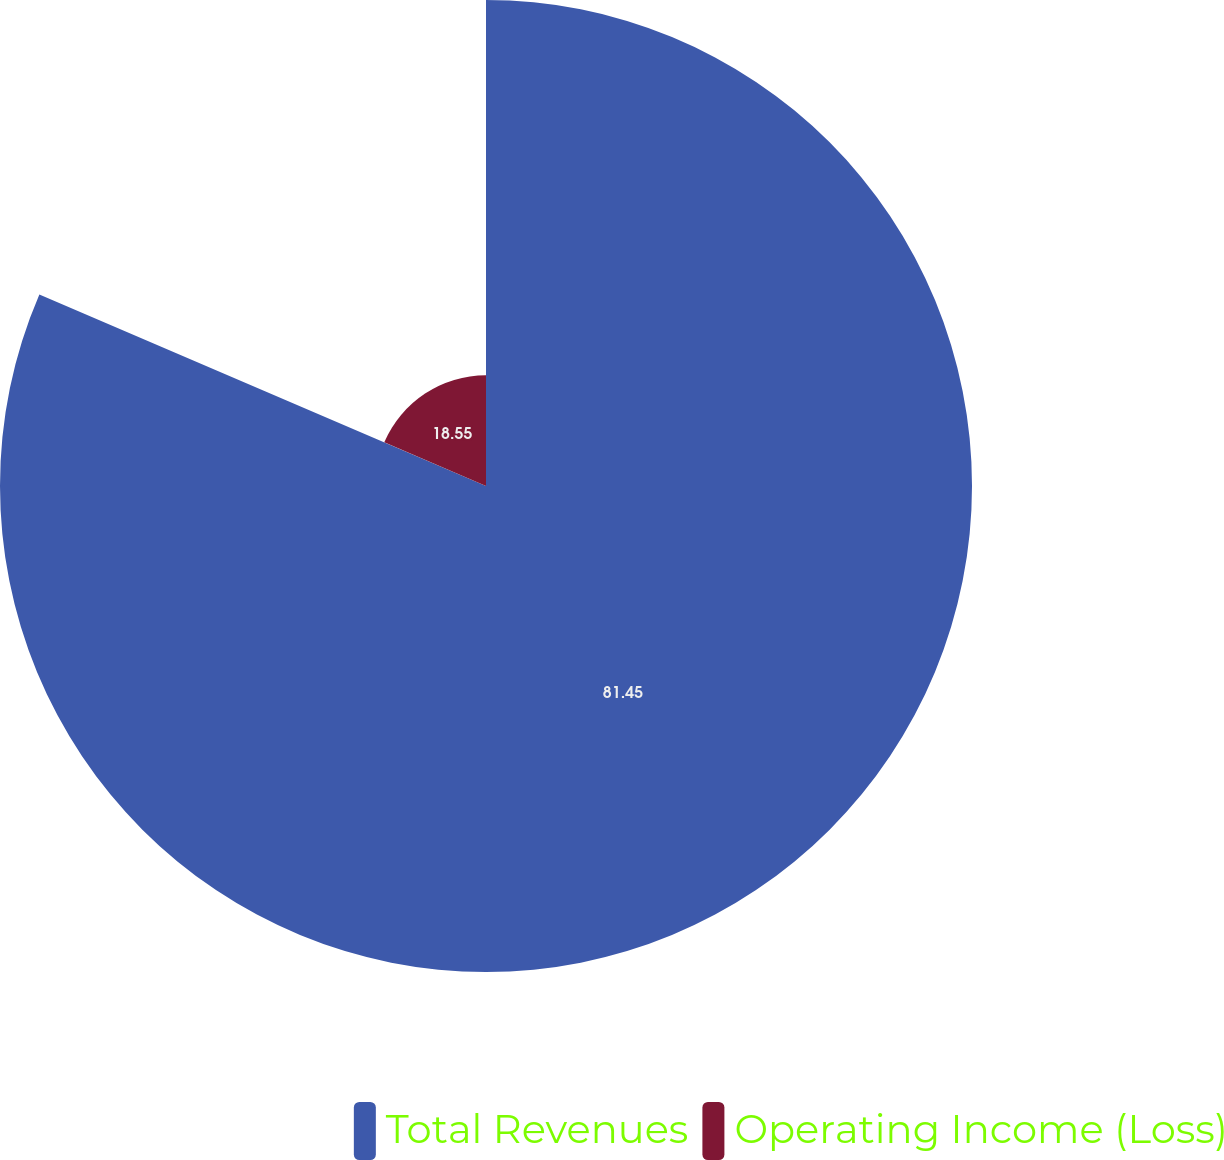Convert chart to OTSL. <chart><loc_0><loc_0><loc_500><loc_500><pie_chart><fcel>Total Revenues<fcel>Operating Income (Loss)<nl><fcel>81.45%<fcel>18.55%<nl></chart> 